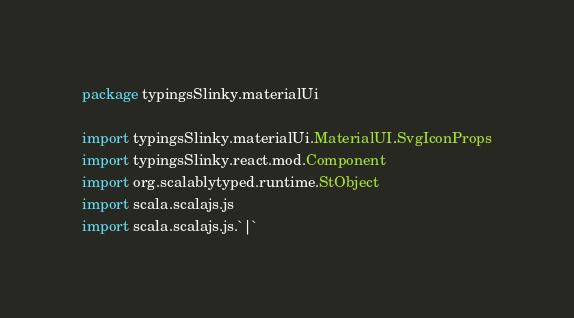Convert code to text. <code><loc_0><loc_0><loc_500><loc_500><_Scala_>package typingsSlinky.materialUi

import typingsSlinky.materialUi.MaterialUI.SvgIconProps
import typingsSlinky.react.mod.Component
import org.scalablytyped.runtime.StObject
import scala.scalajs.js
import scala.scalajs.js.`|`</code> 